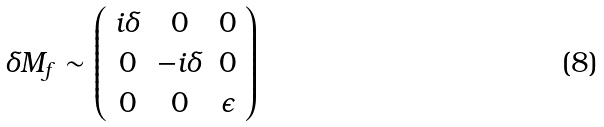Convert formula to latex. <formula><loc_0><loc_0><loc_500><loc_500>\delta M _ { f } \sim \left ( \begin{array} { c c c } i \delta & 0 & 0 \\ 0 & - i \delta & 0 \\ 0 & 0 & \epsilon \end{array} \right )</formula> 